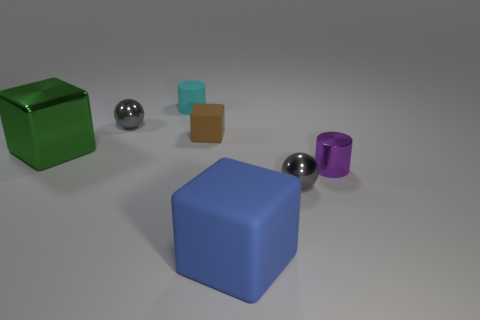How many cubes are in front of the big green thing and left of the big blue rubber block? There is one small brown cube located in front of the large green cube and to the left of the big blue rubber block, as viewed from the camera's perspective. 